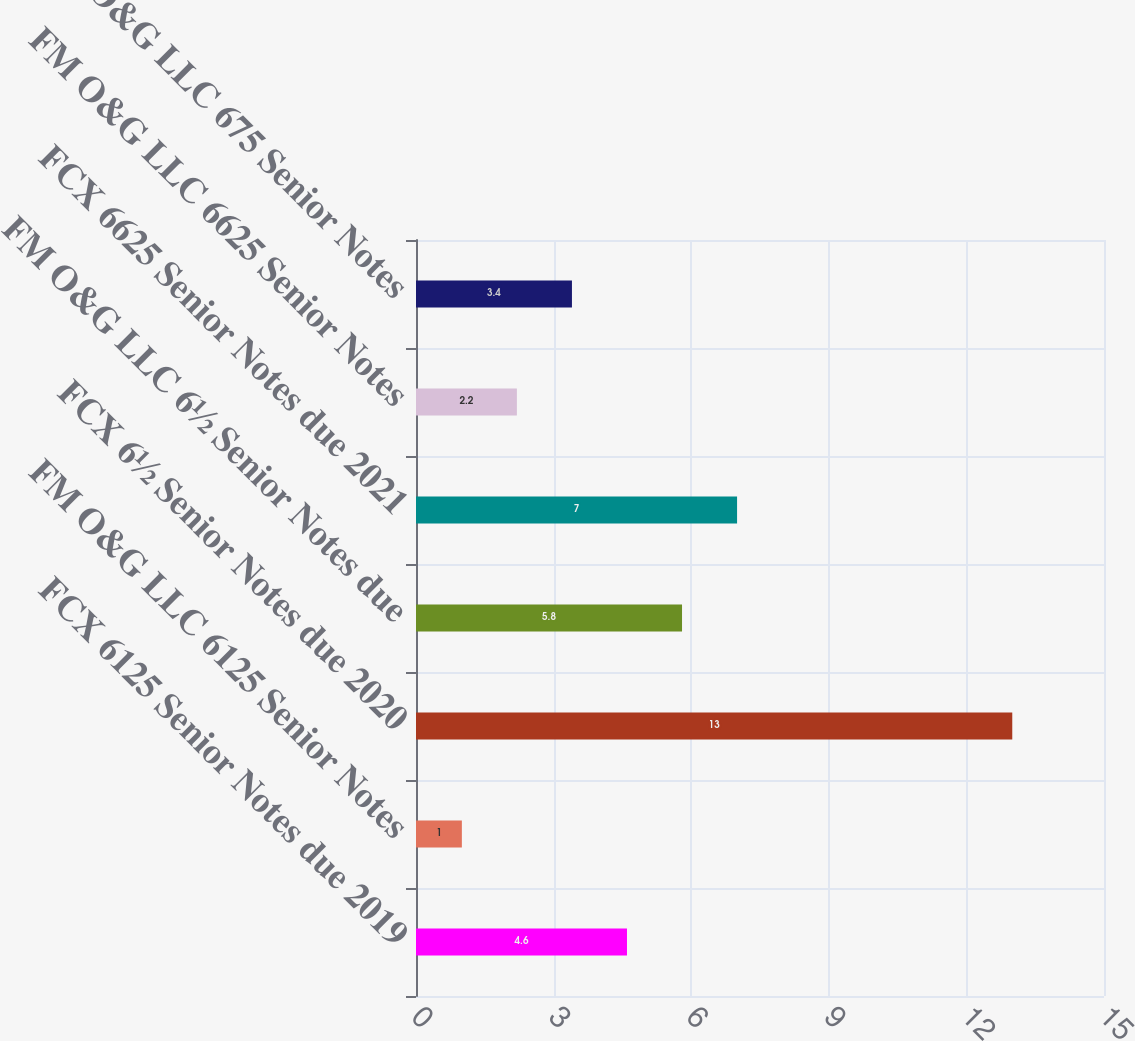Convert chart. <chart><loc_0><loc_0><loc_500><loc_500><bar_chart><fcel>FCX 6125 Senior Notes due 2019<fcel>FM O&G LLC 6125 Senior Notes<fcel>FCX 6½ Senior Notes due 2020<fcel>FM O&G LLC 6½ Senior Notes due<fcel>FCX 6625 Senior Notes due 2021<fcel>FM O&G LLC 6625 Senior Notes<fcel>FM O&G LLC 675 Senior Notes<nl><fcel>4.6<fcel>1<fcel>13<fcel>5.8<fcel>7<fcel>2.2<fcel>3.4<nl></chart> 